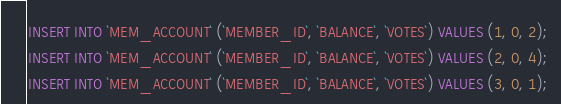<code> <loc_0><loc_0><loc_500><loc_500><_SQL_>INSERT INTO `MEM_ACCOUNT` (`MEMBER_ID`, `BALANCE`, `VOTES`) VALUES (1, 0, 2);
INSERT INTO `MEM_ACCOUNT` (`MEMBER_ID`, `BALANCE`, `VOTES`) VALUES (2, 0, 4);
INSERT INTO `MEM_ACCOUNT` (`MEMBER_ID`, `BALANCE`, `VOTES`) VALUES (3, 0, 1);
</code> 